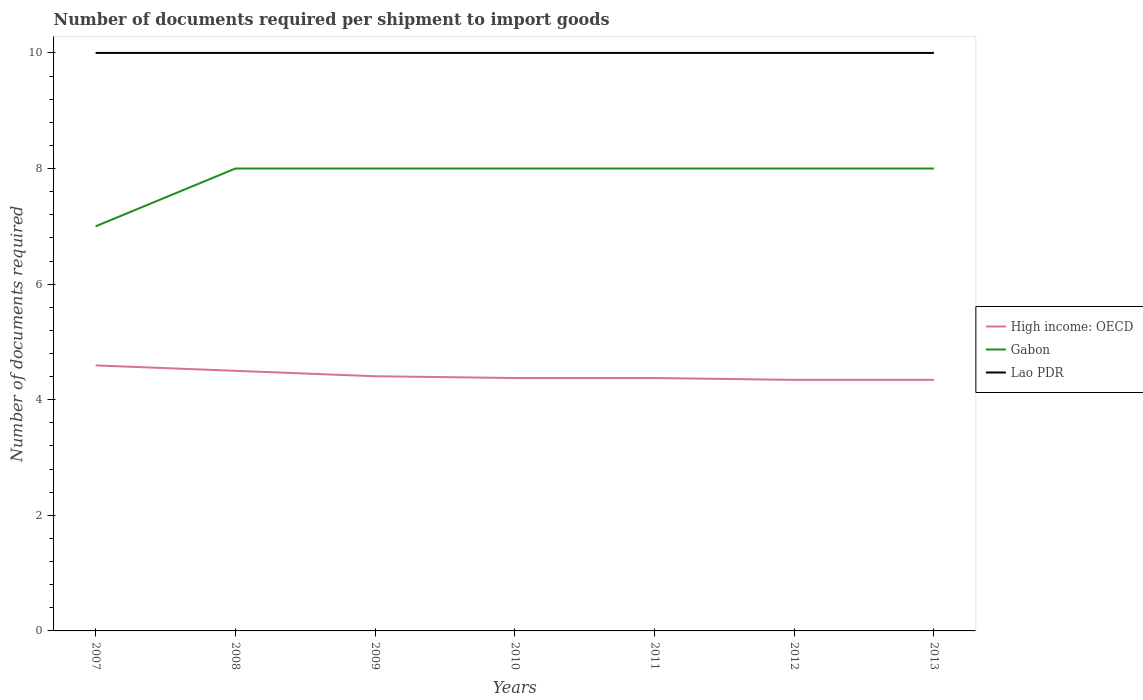How many different coloured lines are there?
Give a very brief answer. 3. Does the line corresponding to Gabon intersect with the line corresponding to High income: OECD?
Make the answer very short. No. Is the number of lines equal to the number of legend labels?
Your answer should be compact. Yes. Across all years, what is the maximum number of documents required per shipment to import goods in High income: OECD?
Offer a terse response. 4.34. In which year was the number of documents required per shipment to import goods in Lao PDR maximum?
Offer a very short reply. 2007. What is the total number of documents required per shipment to import goods in High income: OECD in the graph?
Your answer should be compact. 0.03. What is the difference between the highest and the second highest number of documents required per shipment to import goods in Gabon?
Keep it short and to the point. 1. What is the difference between the highest and the lowest number of documents required per shipment to import goods in Gabon?
Keep it short and to the point. 6. What is the difference between two consecutive major ticks on the Y-axis?
Your response must be concise. 2. Are the values on the major ticks of Y-axis written in scientific E-notation?
Provide a short and direct response. No. Does the graph contain any zero values?
Offer a terse response. No. Does the graph contain grids?
Ensure brevity in your answer.  No. Where does the legend appear in the graph?
Give a very brief answer. Center right. What is the title of the graph?
Your response must be concise. Number of documents required per shipment to import goods. Does "Andorra" appear as one of the legend labels in the graph?
Give a very brief answer. No. What is the label or title of the Y-axis?
Make the answer very short. Number of documents required. What is the Number of documents required in High income: OECD in 2007?
Give a very brief answer. 4.59. What is the Number of documents required in Gabon in 2008?
Provide a succinct answer. 8. What is the Number of documents required in Lao PDR in 2008?
Ensure brevity in your answer.  10. What is the Number of documents required of High income: OECD in 2009?
Offer a very short reply. 4.41. What is the Number of documents required of Lao PDR in 2009?
Keep it short and to the point. 10. What is the Number of documents required of High income: OECD in 2010?
Keep it short and to the point. 4.38. What is the Number of documents required in Gabon in 2010?
Your response must be concise. 8. What is the Number of documents required of High income: OECD in 2011?
Give a very brief answer. 4.38. What is the Number of documents required of Gabon in 2011?
Your answer should be very brief. 8. What is the Number of documents required in Lao PDR in 2011?
Give a very brief answer. 10. What is the Number of documents required in High income: OECD in 2012?
Offer a terse response. 4.34. What is the Number of documents required of Gabon in 2012?
Your response must be concise. 8. What is the Number of documents required of Lao PDR in 2012?
Keep it short and to the point. 10. What is the Number of documents required of High income: OECD in 2013?
Keep it short and to the point. 4.34. What is the Number of documents required of Lao PDR in 2013?
Keep it short and to the point. 10. Across all years, what is the maximum Number of documents required in High income: OECD?
Provide a short and direct response. 4.59. Across all years, what is the maximum Number of documents required of Lao PDR?
Ensure brevity in your answer.  10. Across all years, what is the minimum Number of documents required in High income: OECD?
Keep it short and to the point. 4.34. What is the total Number of documents required in High income: OECD in the graph?
Your answer should be very brief. 30.94. What is the difference between the Number of documents required in High income: OECD in 2007 and that in 2008?
Provide a short and direct response. 0.09. What is the difference between the Number of documents required in Gabon in 2007 and that in 2008?
Give a very brief answer. -1. What is the difference between the Number of documents required in Lao PDR in 2007 and that in 2008?
Provide a short and direct response. 0. What is the difference between the Number of documents required in High income: OECD in 2007 and that in 2009?
Offer a terse response. 0.19. What is the difference between the Number of documents required in High income: OECD in 2007 and that in 2010?
Offer a very short reply. 0.22. What is the difference between the Number of documents required of Gabon in 2007 and that in 2010?
Provide a short and direct response. -1. What is the difference between the Number of documents required of High income: OECD in 2007 and that in 2011?
Ensure brevity in your answer.  0.22. What is the difference between the Number of documents required in Gabon in 2007 and that in 2011?
Make the answer very short. -1. What is the difference between the Number of documents required in Lao PDR in 2007 and that in 2011?
Your answer should be compact. 0. What is the difference between the Number of documents required in Gabon in 2007 and that in 2012?
Provide a succinct answer. -1. What is the difference between the Number of documents required in Gabon in 2007 and that in 2013?
Make the answer very short. -1. What is the difference between the Number of documents required in High income: OECD in 2008 and that in 2009?
Provide a short and direct response. 0.09. What is the difference between the Number of documents required in Gabon in 2008 and that in 2009?
Your answer should be compact. 0. What is the difference between the Number of documents required in High income: OECD in 2008 and that in 2010?
Give a very brief answer. 0.12. What is the difference between the Number of documents required of Lao PDR in 2008 and that in 2010?
Give a very brief answer. 0. What is the difference between the Number of documents required in Lao PDR in 2008 and that in 2011?
Make the answer very short. 0. What is the difference between the Number of documents required in High income: OECD in 2008 and that in 2012?
Provide a succinct answer. 0.16. What is the difference between the Number of documents required of Gabon in 2008 and that in 2012?
Your answer should be compact. 0. What is the difference between the Number of documents required of Lao PDR in 2008 and that in 2012?
Your answer should be compact. 0. What is the difference between the Number of documents required in High income: OECD in 2008 and that in 2013?
Provide a succinct answer. 0.16. What is the difference between the Number of documents required of Gabon in 2008 and that in 2013?
Give a very brief answer. 0. What is the difference between the Number of documents required in High income: OECD in 2009 and that in 2010?
Keep it short and to the point. 0.03. What is the difference between the Number of documents required of High income: OECD in 2009 and that in 2011?
Provide a short and direct response. 0.03. What is the difference between the Number of documents required in Lao PDR in 2009 and that in 2011?
Your answer should be very brief. 0. What is the difference between the Number of documents required in High income: OECD in 2009 and that in 2012?
Provide a succinct answer. 0.06. What is the difference between the Number of documents required in High income: OECD in 2009 and that in 2013?
Offer a very short reply. 0.06. What is the difference between the Number of documents required in High income: OECD in 2010 and that in 2011?
Keep it short and to the point. 0. What is the difference between the Number of documents required of Gabon in 2010 and that in 2011?
Your response must be concise. 0. What is the difference between the Number of documents required in Lao PDR in 2010 and that in 2011?
Give a very brief answer. 0. What is the difference between the Number of documents required of High income: OECD in 2010 and that in 2012?
Offer a very short reply. 0.03. What is the difference between the Number of documents required of High income: OECD in 2010 and that in 2013?
Your response must be concise. 0.03. What is the difference between the Number of documents required of High income: OECD in 2011 and that in 2012?
Offer a terse response. 0.03. What is the difference between the Number of documents required of Gabon in 2011 and that in 2012?
Your answer should be compact. 0. What is the difference between the Number of documents required in High income: OECD in 2011 and that in 2013?
Make the answer very short. 0.03. What is the difference between the Number of documents required of Gabon in 2011 and that in 2013?
Offer a terse response. 0. What is the difference between the Number of documents required in High income: OECD in 2012 and that in 2013?
Ensure brevity in your answer.  0. What is the difference between the Number of documents required of Gabon in 2012 and that in 2013?
Give a very brief answer. 0. What is the difference between the Number of documents required in Lao PDR in 2012 and that in 2013?
Offer a terse response. 0. What is the difference between the Number of documents required in High income: OECD in 2007 and the Number of documents required in Gabon in 2008?
Your response must be concise. -3.41. What is the difference between the Number of documents required of High income: OECD in 2007 and the Number of documents required of Lao PDR in 2008?
Your answer should be compact. -5.41. What is the difference between the Number of documents required in Gabon in 2007 and the Number of documents required in Lao PDR in 2008?
Make the answer very short. -3. What is the difference between the Number of documents required of High income: OECD in 2007 and the Number of documents required of Gabon in 2009?
Make the answer very short. -3.41. What is the difference between the Number of documents required in High income: OECD in 2007 and the Number of documents required in Lao PDR in 2009?
Provide a short and direct response. -5.41. What is the difference between the Number of documents required of Gabon in 2007 and the Number of documents required of Lao PDR in 2009?
Your answer should be very brief. -3. What is the difference between the Number of documents required of High income: OECD in 2007 and the Number of documents required of Gabon in 2010?
Give a very brief answer. -3.41. What is the difference between the Number of documents required of High income: OECD in 2007 and the Number of documents required of Lao PDR in 2010?
Offer a very short reply. -5.41. What is the difference between the Number of documents required of Gabon in 2007 and the Number of documents required of Lao PDR in 2010?
Provide a succinct answer. -3. What is the difference between the Number of documents required of High income: OECD in 2007 and the Number of documents required of Gabon in 2011?
Provide a short and direct response. -3.41. What is the difference between the Number of documents required in High income: OECD in 2007 and the Number of documents required in Lao PDR in 2011?
Your answer should be very brief. -5.41. What is the difference between the Number of documents required of High income: OECD in 2007 and the Number of documents required of Gabon in 2012?
Offer a terse response. -3.41. What is the difference between the Number of documents required in High income: OECD in 2007 and the Number of documents required in Lao PDR in 2012?
Give a very brief answer. -5.41. What is the difference between the Number of documents required of Gabon in 2007 and the Number of documents required of Lao PDR in 2012?
Keep it short and to the point. -3. What is the difference between the Number of documents required in High income: OECD in 2007 and the Number of documents required in Gabon in 2013?
Your response must be concise. -3.41. What is the difference between the Number of documents required of High income: OECD in 2007 and the Number of documents required of Lao PDR in 2013?
Your answer should be very brief. -5.41. What is the difference between the Number of documents required in Gabon in 2007 and the Number of documents required in Lao PDR in 2013?
Your answer should be compact. -3. What is the difference between the Number of documents required of High income: OECD in 2008 and the Number of documents required of Gabon in 2010?
Provide a succinct answer. -3.5. What is the difference between the Number of documents required of Gabon in 2008 and the Number of documents required of Lao PDR in 2010?
Provide a short and direct response. -2. What is the difference between the Number of documents required of High income: OECD in 2008 and the Number of documents required of Lao PDR in 2011?
Your answer should be compact. -5.5. What is the difference between the Number of documents required in High income: OECD in 2008 and the Number of documents required in Lao PDR in 2013?
Ensure brevity in your answer.  -5.5. What is the difference between the Number of documents required in High income: OECD in 2009 and the Number of documents required in Gabon in 2010?
Keep it short and to the point. -3.59. What is the difference between the Number of documents required of High income: OECD in 2009 and the Number of documents required of Lao PDR in 2010?
Your answer should be compact. -5.59. What is the difference between the Number of documents required of High income: OECD in 2009 and the Number of documents required of Gabon in 2011?
Offer a terse response. -3.59. What is the difference between the Number of documents required of High income: OECD in 2009 and the Number of documents required of Lao PDR in 2011?
Offer a very short reply. -5.59. What is the difference between the Number of documents required in Gabon in 2009 and the Number of documents required in Lao PDR in 2011?
Your response must be concise. -2. What is the difference between the Number of documents required in High income: OECD in 2009 and the Number of documents required in Gabon in 2012?
Provide a succinct answer. -3.59. What is the difference between the Number of documents required in High income: OECD in 2009 and the Number of documents required in Lao PDR in 2012?
Provide a succinct answer. -5.59. What is the difference between the Number of documents required in High income: OECD in 2009 and the Number of documents required in Gabon in 2013?
Provide a succinct answer. -3.59. What is the difference between the Number of documents required of High income: OECD in 2009 and the Number of documents required of Lao PDR in 2013?
Make the answer very short. -5.59. What is the difference between the Number of documents required in High income: OECD in 2010 and the Number of documents required in Gabon in 2011?
Your answer should be compact. -3.62. What is the difference between the Number of documents required in High income: OECD in 2010 and the Number of documents required in Lao PDR in 2011?
Your response must be concise. -5.62. What is the difference between the Number of documents required in Gabon in 2010 and the Number of documents required in Lao PDR in 2011?
Keep it short and to the point. -2. What is the difference between the Number of documents required in High income: OECD in 2010 and the Number of documents required in Gabon in 2012?
Provide a short and direct response. -3.62. What is the difference between the Number of documents required in High income: OECD in 2010 and the Number of documents required in Lao PDR in 2012?
Provide a short and direct response. -5.62. What is the difference between the Number of documents required of High income: OECD in 2010 and the Number of documents required of Gabon in 2013?
Offer a very short reply. -3.62. What is the difference between the Number of documents required in High income: OECD in 2010 and the Number of documents required in Lao PDR in 2013?
Your answer should be very brief. -5.62. What is the difference between the Number of documents required in Gabon in 2010 and the Number of documents required in Lao PDR in 2013?
Give a very brief answer. -2. What is the difference between the Number of documents required in High income: OECD in 2011 and the Number of documents required in Gabon in 2012?
Provide a short and direct response. -3.62. What is the difference between the Number of documents required in High income: OECD in 2011 and the Number of documents required in Lao PDR in 2012?
Give a very brief answer. -5.62. What is the difference between the Number of documents required in Gabon in 2011 and the Number of documents required in Lao PDR in 2012?
Ensure brevity in your answer.  -2. What is the difference between the Number of documents required of High income: OECD in 2011 and the Number of documents required of Gabon in 2013?
Your response must be concise. -3.62. What is the difference between the Number of documents required of High income: OECD in 2011 and the Number of documents required of Lao PDR in 2013?
Make the answer very short. -5.62. What is the difference between the Number of documents required in High income: OECD in 2012 and the Number of documents required in Gabon in 2013?
Offer a terse response. -3.66. What is the difference between the Number of documents required of High income: OECD in 2012 and the Number of documents required of Lao PDR in 2013?
Ensure brevity in your answer.  -5.66. What is the average Number of documents required of High income: OECD per year?
Offer a very short reply. 4.42. What is the average Number of documents required in Gabon per year?
Ensure brevity in your answer.  7.86. What is the average Number of documents required of Lao PDR per year?
Make the answer very short. 10. In the year 2007, what is the difference between the Number of documents required in High income: OECD and Number of documents required in Gabon?
Your answer should be compact. -2.41. In the year 2007, what is the difference between the Number of documents required of High income: OECD and Number of documents required of Lao PDR?
Give a very brief answer. -5.41. In the year 2007, what is the difference between the Number of documents required in Gabon and Number of documents required in Lao PDR?
Your answer should be very brief. -3. In the year 2008, what is the difference between the Number of documents required of High income: OECD and Number of documents required of Gabon?
Your answer should be very brief. -3.5. In the year 2008, what is the difference between the Number of documents required of Gabon and Number of documents required of Lao PDR?
Offer a very short reply. -2. In the year 2009, what is the difference between the Number of documents required in High income: OECD and Number of documents required in Gabon?
Provide a short and direct response. -3.59. In the year 2009, what is the difference between the Number of documents required of High income: OECD and Number of documents required of Lao PDR?
Offer a very short reply. -5.59. In the year 2010, what is the difference between the Number of documents required of High income: OECD and Number of documents required of Gabon?
Give a very brief answer. -3.62. In the year 2010, what is the difference between the Number of documents required in High income: OECD and Number of documents required in Lao PDR?
Your answer should be compact. -5.62. In the year 2010, what is the difference between the Number of documents required in Gabon and Number of documents required in Lao PDR?
Provide a short and direct response. -2. In the year 2011, what is the difference between the Number of documents required in High income: OECD and Number of documents required in Gabon?
Provide a short and direct response. -3.62. In the year 2011, what is the difference between the Number of documents required in High income: OECD and Number of documents required in Lao PDR?
Your answer should be compact. -5.62. In the year 2012, what is the difference between the Number of documents required in High income: OECD and Number of documents required in Gabon?
Provide a succinct answer. -3.66. In the year 2012, what is the difference between the Number of documents required in High income: OECD and Number of documents required in Lao PDR?
Ensure brevity in your answer.  -5.66. In the year 2013, what is the difference between the Number of documents required of High income: OECD and Number of documents required of Gabon?
Offer a very short reply. -3.66. In the year 2013, what is the difference between the Number of documents required of High income: OECD and Number of documents required of Lao PDR?
Your answer should be compact. -5.66. In the year 2013, what is the difference between the Number of documents required in Gabon and Number of documents required in Lao PDR?
Provide a short and direct response. -2. What is the ratio of the Number of documents required of High income: OECD in 2007 to that in 2008?
Your response must be concise. 1.02. What is the ratio of the Number of documents required in Gabon in 2007 to that in 2008?
Your answer should be compact. 0.88. What is the ratio of the Number of documents required in High income: OECD in 2007 to that in 2009?
Your answer should be very brief. 1.04. What is the ratio of the Number of documents required in Lao PDR in 2007 to that in 2009?
Your response must be concise. 1. What is the ratio of the Number of documents required of Lao PDR in 2007 to that in 2010?
Provide a short and direct response. 1. What is the ratio of the Number of documents required of Gabon in 2007 to that in 2011?
Give a very brief answer. 0.88. What is the ratio of the Number of documents required of High income: OECD in 2007 to that in 2012?
Keep it short and to the point. 1.06. What is the ratio of the Number of documents required of Lao PDR in 2007 to that in 2012?
Give a very brief answer. 1. What is the ratio of the Number of documents required in High income: OECD in 2007 to that in 2013?
Ensure brevity in your answer.  1.06. What is the ratio of the Number of documents required of High income: OECD in 2008 to that in 2009?
Offer a terse response. 1.02. What is the ratio of the Number of documents required in Gabon in 2008 to that in 2009?
Ensure brevity in your answer.  1. What is the ratio of the Number of documents required of Lao PDR in 2008 to that in 2009?
Your answer should be compact. 1. What is the ratio of the Number of documents required of High income: OECD in 2008 to that in 2010?
Provide a short and direct response. 1.03. What is the ratio of the Number of documents required in Gabon in 2008 to that in 2010?
Offer a very short reply. 1. What is the ratio of the Number of documents required in Lao PDR in 2008 to that in 2010?
Your response must be concise. 1. What is the ratio of the Number of documents required of High income: OECD in 2008 to that in 2011?
Your answer should be very brief. 1.03. What is the ratio of the Number of documents required of Lao PDR in 2008 to that in 2011?
Provide a succinct answer. 1. What is the ratio of the Number of documents required in High income: OECD in 2008 to that in 2012?
Give a very brief answer. 1.04. What is the ratio of the Number of documents required of High income: OECD in 2008 to that in 2013?
Provide a short and direct response. 1.04. What is the ratio of the Number of documents required of High income: OECD in 2009 to that in 2010?
Your answer should be compact. 1.01. What is the ratio of the Number of documents required of Gabon in 2009 to that in 2010?
Keep it short and to the point. 1. What is the ratio of the Number of documents required in High income: OECD in 2009 to that in 2011?
Your response must be concise. 1.01. What is the ratio of the Number of documents required of Gabon in 2009 to that in 2011?
Make the answer very short. 1. What is the ratio of the Number of documents required in High income: OECD in 2009 to that in 2012?
Give a very brief answer. 1.01. What is the ratio of the Number of documents required of Lao PDR in 2009 to that in 2012?
Your answer should be very brief. 1. What is the ratio of the Number of documents required in High income: OECD in 2009 to that in 2013?
Your answer should be compact. 1.01. What is the ratio of the Number of documents required in High income: OECD in 2010 to that in 2011?
Your response must be concise. 1. What is the ratio of the Number of documents required of High income: OECD in 2010 to that in 2012?
Offer a terse response. 1.01. What is the ratio of the Number of documents required of Lao PDR in 2010 to that in 2012?
Provide a succinct answer. 1. What is the ratio of the Number of documents required of High income: OECD in 2010 to that in 2013?
Your answer should be very brief. 1.01. What is the ratio of the Number of documents required in Gabon in 2011 to that in 2012?
Give a very brief answer. 1. What is the ratio of the Number of documents required in Lao PDR in 2011 to that in 2013?
Make the answer very short. 1. What is the ratio of the Number of documents required in High income: OECD in 2012 to that in 2013?
Give a very brief answer. 1. What is the ratio of the Number of documents required in Gabon in 2012 to that in 2013?
Give a very brief answer. 1. What is the ratio of the Number of documents required of Lao PDR in 2012 to that in 2013?
Provide a short and direct response. 1. What is the difference between the highest and the second highest Number of documents required of High income: OECD?
Provide a succinct answer. 0.09. What is the difference between the highest and the second highest Number of documents required of Lao PDR?
Your answer should be compact. 0. What is the difference between the highest and the lowest Number of documents required of Gabon?
Make the answer very short. 1. 